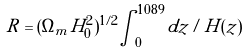Convert formula to latex. <formula><loc_0><loc_0><loc_500><loc_500>R = ( \Omega _ { m } H _ { 0 } ^ { 2 } ) ^ { 1 / 2 } \int _ { 0 } ^ { 1 0 8 9 } d z / H ( z )</formula> 